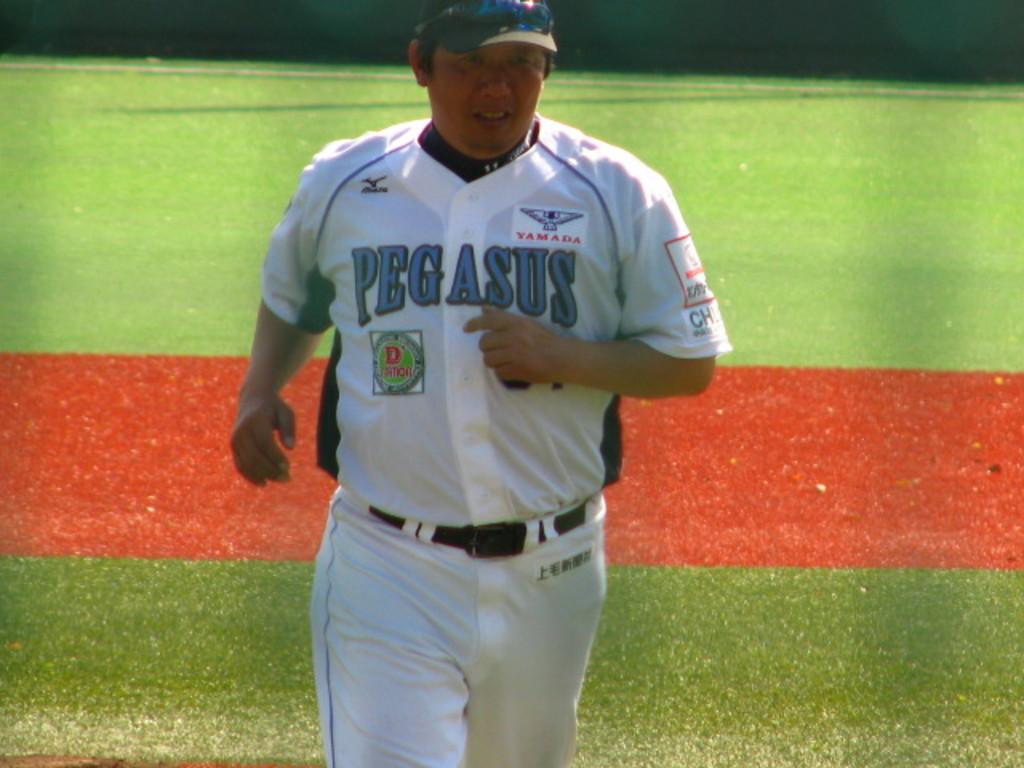What letter is in the green circle?
Offer a terse response. D. 